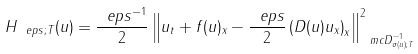Convert formula to latex. <formula><loc_0><loc_0><loc_500><loc_500>H _ { \ e p s ; T } ( u ) = \frac { \ e p s ^ { - 1 } } { 2 } \left \| u _ { t } + f ( u ) _ { x } - \frac { \ e p s } 2 \left ( D ( u ) u _ { x } \right ) _ { x } \right \| _ { \ m c D ^ { - 1 } _ { \sigma ( u ) ; T } } ^ { 2 }</formula> 